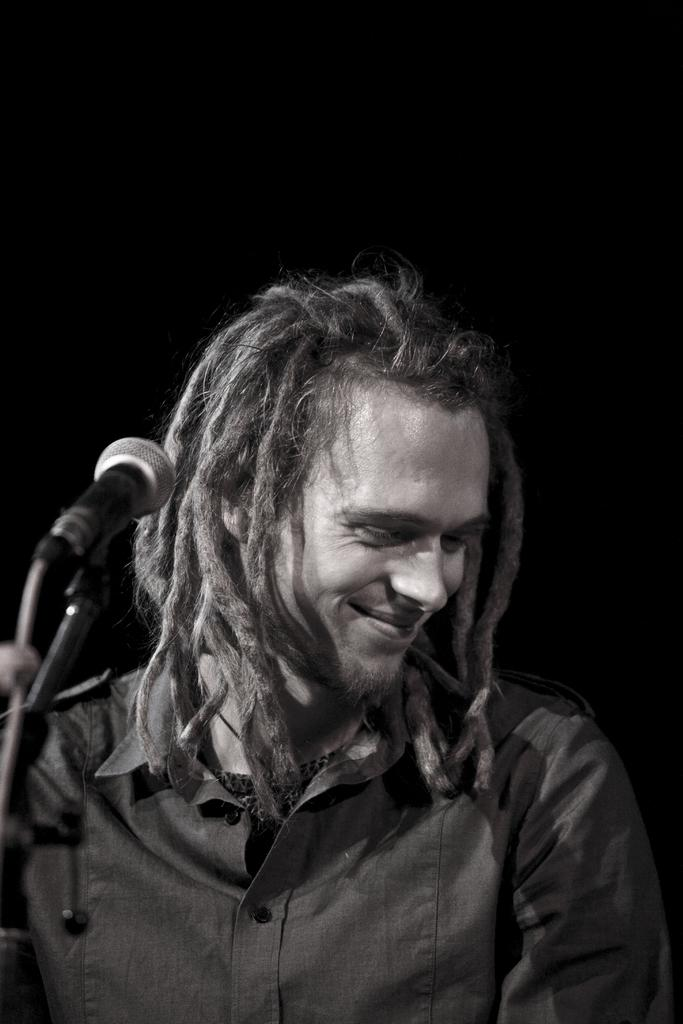Who is the main subject in the image? There is a man in the middle of the image. What object is located on the left side of the image? There is a mic on the left side of the image. What can be observed about the background of the image? The background of the image is dark. What types of cats are visible in the image? There are no cats present in the image. What hobbies does the man in the image have? The provided facts do not give any information about the man's hobbies. 